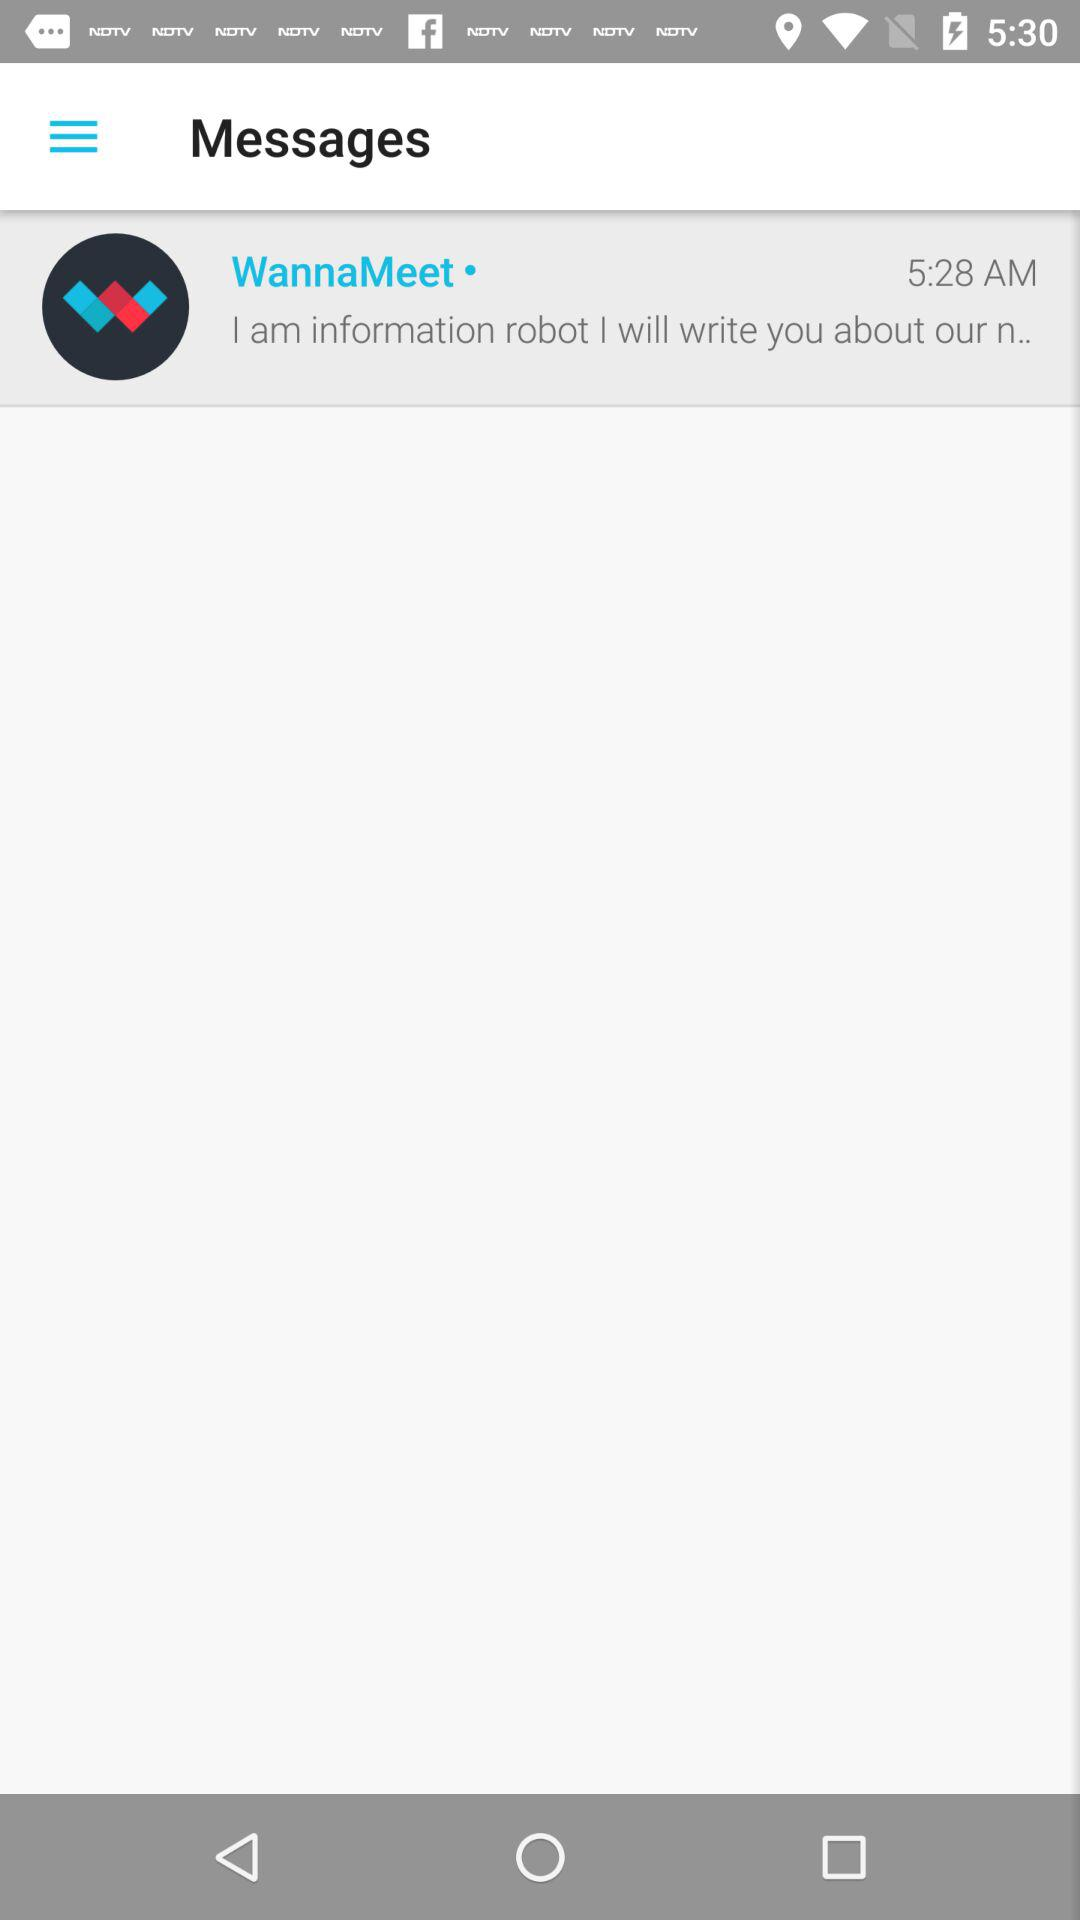What is the time of the message received from "WannaMeet"? The time of the received message is 5:28 AM. 